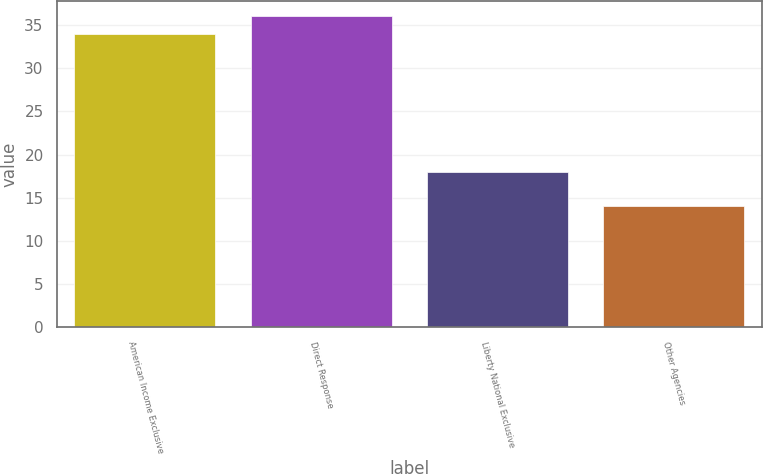<chart> <loc_0><loc_0><loc_500><loc_500><bar_chart><fcel>American Income Exclusive<fcel>Direct Response<fcel>Liberty National Exclusive<fcel>Other Agencies<nl><fcel>34<fcel>36<fcel>18<fcel>14<nl></chart> 